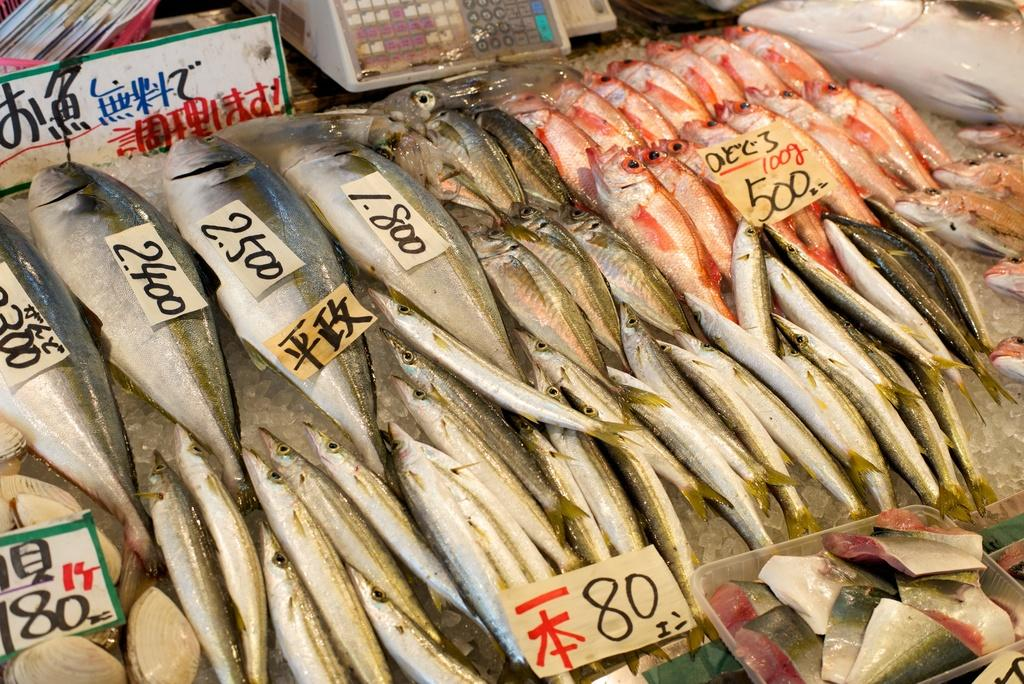What can be seen in the foreground of the picture? There are fishes with rate tags in the foreground of the picture. What is located at the top of the image? There are papers and a name plate at the top of the image. What type of object is present at the top of the image? There is a machine at the top of the image. How many spiders are crawling on the fishes in the image? There are no spiders present in the image; it features fishes with rate tags. What type of market is depicted in the image? The image does not depict a market; it shows fishes with rate tags, papers, a name plate, and a machine. 